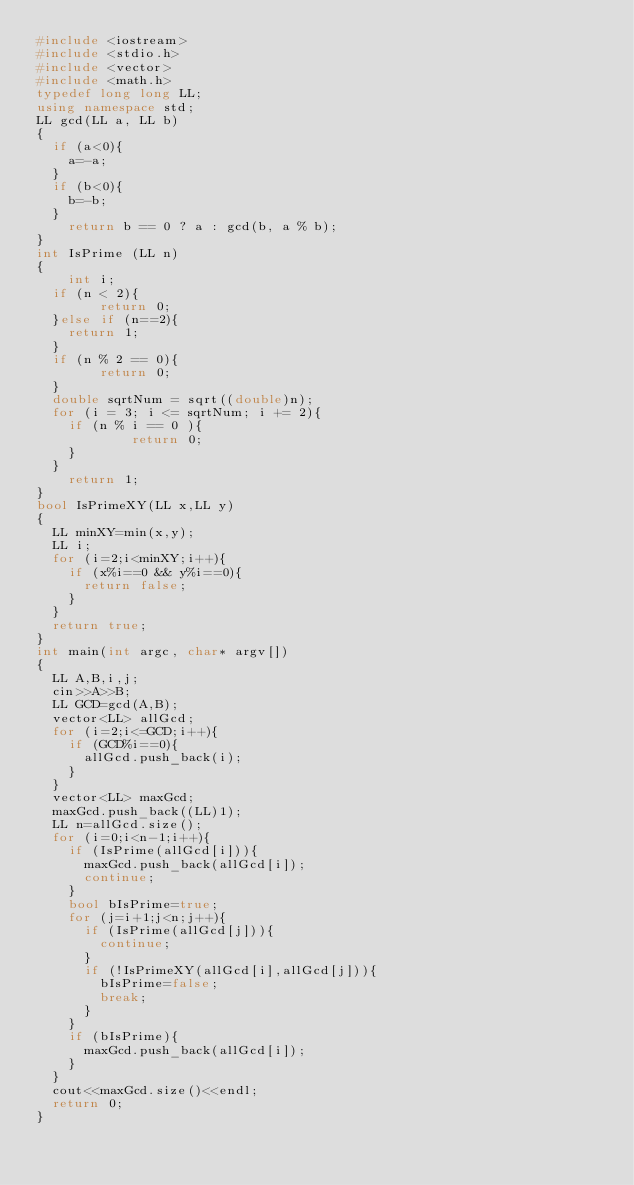<code> <loc_0><loc_0><loc_500><loc_500><_C++_>#include <iostream>
#include <stdio.h>
#include <vector>
#include <math.h>
typedef long long LL;
using namespace std;
LL gcd(LL a, LL b)
{
	if (a<0){
		a=-a;
	}
	if (b<0){
		b=-b;
	}
    return b == 0 ? a : gcd(b, a % b);
}
int IsPrime (LL n)
{
    int i;
	if (n < 2){
        return 0;
	}else if (n==2){
		return 1;
	}
	if (n % 2 == 0){
        return 0;
	}
	double sqrtNum = sqrt((double)n);
	for (i = 3; i <= sqrtNum; i += 2){
		if (n % i == 0 ){
            return 0;
		}
	}
    return 1;
}
bool IsPrimeXY(LL x,LL y)
{
	LL minXY=min(x,y);
	LL i;
	for (i=2;i<minXY;i++){
		if (x%i==0 && y%i==0){
			return false;
		}
	}
	return true;
}
int main(int argc, char* argv[])
{
	LL A,B,i,j;
	cin>>A>>B;
	LL GCD=gcd(A,B);
	vector<LL> allGcd;
	for (i=2;i<=GCD;i++){
		if (GCD%i==0){
			allGcd.push_back(i);
		}
	}
	vector<LL> maxGcd;
	maxGcd.push_back((LL)1);
	LL n=allGcd.size();
	for (i=0;i<n-1;i++){
		if (IsPrime(allGcd[i])){
			maxGcd.push_back(allGcd[i]);
			continue;
		}
		bool bIsPrime=true;
		for (j=i+1;j<n;j++){
			if (IsPrime(allGcd[j])){
				continue;
			}
			if (!IsPrimeXY(allGcd[i],allGcd[j])){
				bIsPrime=false;
				break;
			}
		}
		if (bIsPrime){
			maxGcd.push_back(allGcd[i]);
		}
	}
	cout<<maxGcd.size()<<endl;
	return 0;
}</code> 